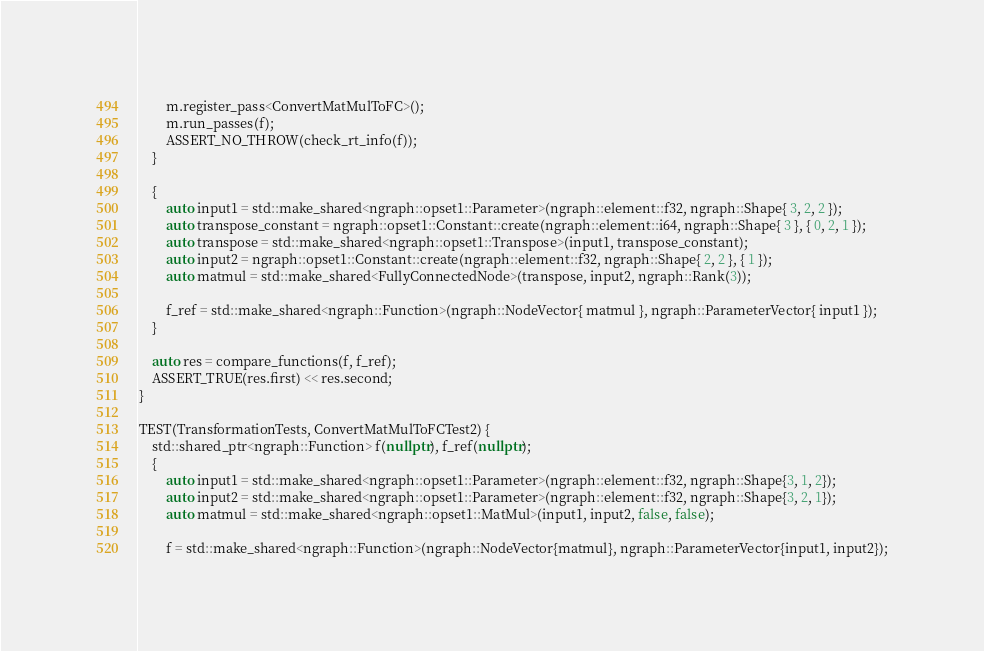Convert code to text. <code><loc_0><loc_0><loc_500><loc_500><_C++_>        m.register_pass<ConvertMatMulToFC>();
        m.run_passes(f);
        ASSERT_NO_THROW(check_rt_info(f));
    }

    {
        auto input1 = std::make_shared<ngraph::opset1::Parameter>(ngraph::element::f32, ngraph::Shape{ 3, 2, 2 });
        auto transpose_constant = ngraph::opset1::Constant::create(ngraph::element::i64, ngraph::Shape{ 3 }, { 0, 2, 1 });
        auto transpose = std::make_shared<ngraph::opset1::Transpose>(input1, transpose_constant);
        auto input2 = ngraph::opset1::Constant::create(ngraph::element::f32, ngraph::Shape{ 2, 2 }, { 1 });
        auto matmul = std::make_shared<FullyConnectedNode>(transpose, input2, ngraph::Rank(3));

        f_ref = std::make_shared<ngraph::Function>(ngraph::NodeVector{ matmul }, ngraph::ParameterVector{ input1 });
    }

    auto res = compare_functions(f, f_ref);
    ASSERT_TRUE(res.first) << res.second;
}

TEST(TransformationTests, ConvertMatMulToFCTest2) {
    std::shared_ptr<ngraph::Function> f(nullptr), f_ref(nullptr);
    {
        auto input1 = std::make_shared<ngraph::opset1::Parameter>(ngraph::element::f32, ngraph::Shape{3, 1, 2});
        auto input2 = std::make_shared<ngraph::opset1::Parameter>(ngraph::element::f32, ngraph::Shape{3, 2, 1});
        auto matmul = std::make_shared<ngraph::opset1::MatMul>(input1, input2, false, false);

        f = std::make_shared<ngraph::Function>(ngraph::NodeVector{matmul}, ngraph::ParameterVector{input1, input2});</code> 